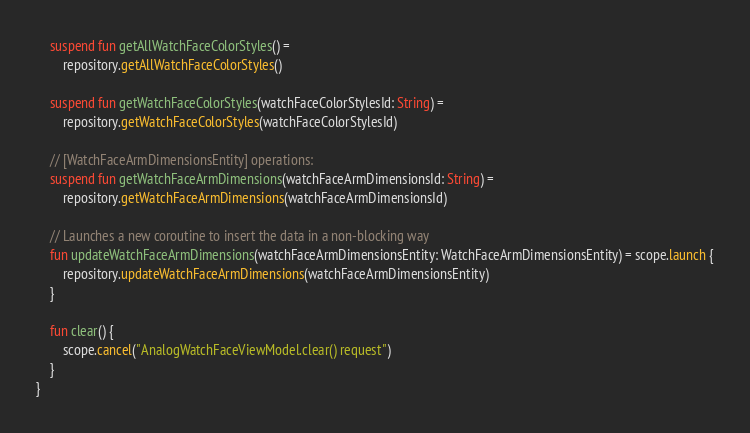<code> <loc_0><loc_0><loc_500><loc_500><_Kotlin_>    suspend fun getAllWatchFaceColorStyles() =
        repository.getAllWatchFaceColorStyles()

    suspend fun getWatchFaceColorStyles(watchFaceColorStylesId: String) =
        repository.getWatchFaceColorStyles(watchFaceColorStylesId)

    // [WatchFaceArmDimensionsEntity] operations:
    suspend fun getWatchFaceArmDimensions(watchFaceArmDimensionsId: String) =
        repository.getWatchFaceArmDimensions(watchFaceArmDimensionsId)

    // Launches a new coroutine to insert the data in a non-blocking way
    fun updateWatchFaceArmDimensions(watchFaceArmDimensionsEntity: WatchFaceArmDimensionsEntity) = scope.launch {
        repository.updateWatchFaceArmDimensions(watchFaceArmDimensionsEntity)
    }

    fun clear() {
        scope.cancel("AnalogWatchFaceViewModel.clear() request")
    }
}
</code> 